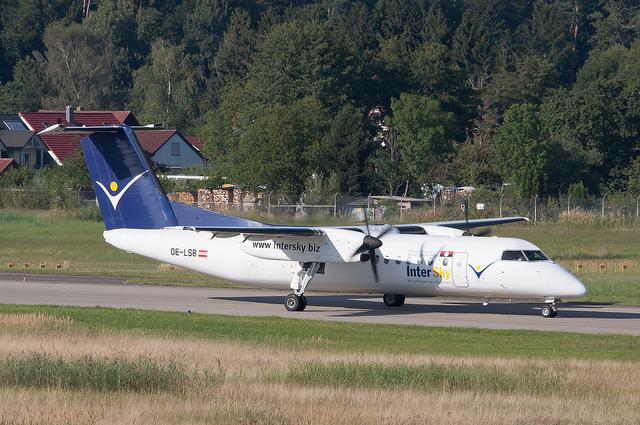How big is the plane?
Keep it brief. Small. Is there a website address on the airplane?
Concise answer only. Yes. Does the yellow circle in the logo on the tail look like it represents a head?
Write a very short answer. Yes. 